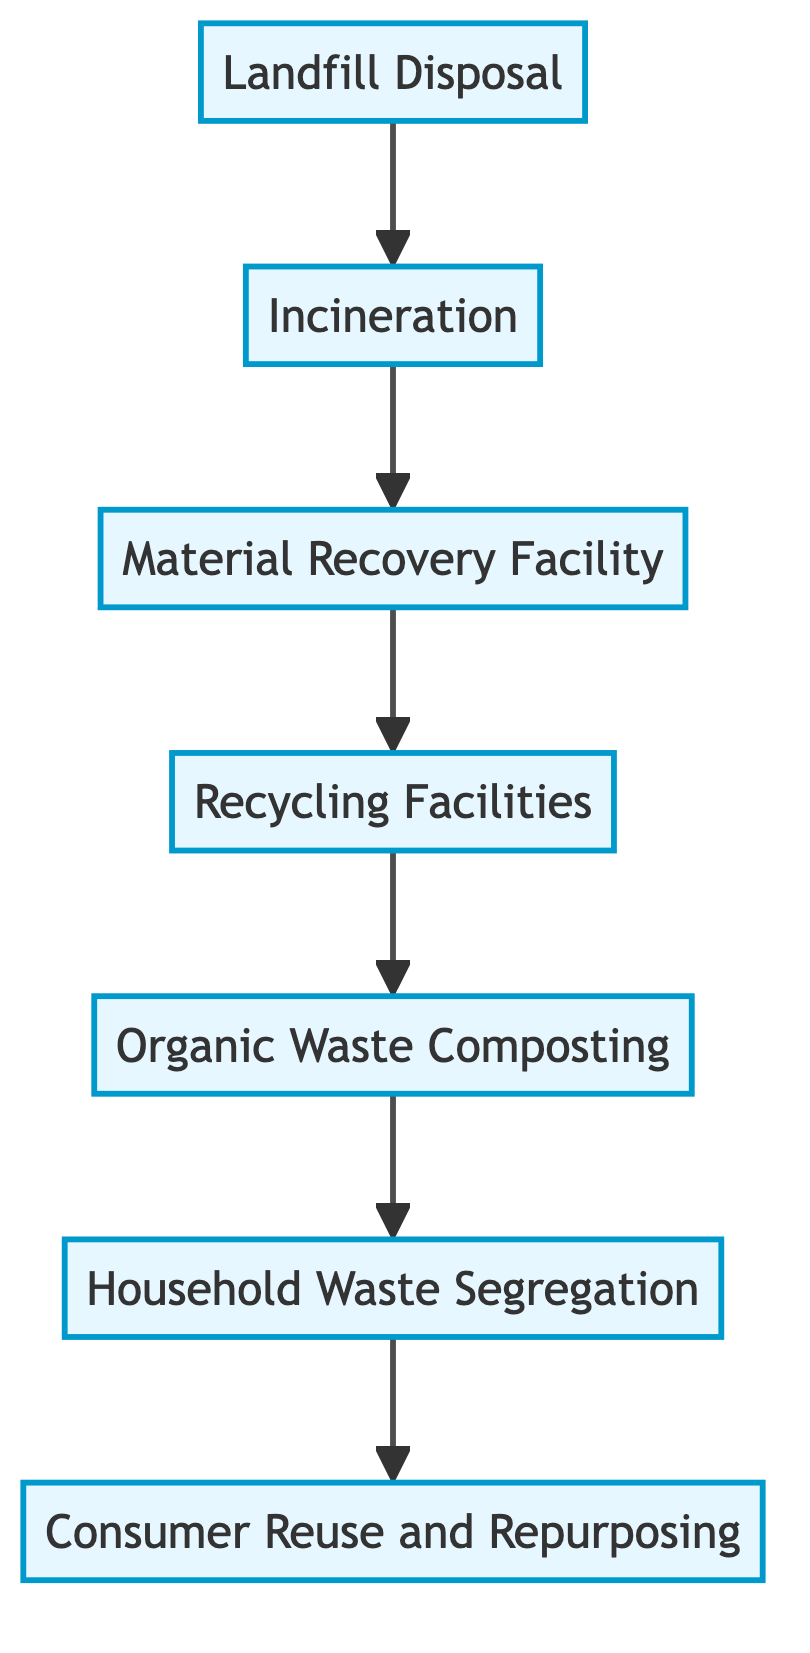What is the first stage in the waste management flow? The flow chart starts at the bottom with Landfill Disposal, which is the initial stage for household waste.
Answer: Landfill Disposal How many stages are there in the waste management process? The flow chart contains a total of seven stages, starting from Landfill Disposal and ending with Consumer Reuse and Repurposing.
Answer: Seven What is the impact of Organic Waste Composting? The diagram states that the impact includes a reduction in landfill use and methane emissions, along with the production of compost.
Answer: Reduction in landfill use and methane emissions Which stage directly precedes Recycling Facilities? The stage directly before Recycling Facilities, according to the flow chart, is the Material Recovery Facility (MRF).
Answer: Material Recovery Facility What type of waste is processed at Recycling Facilities? The Recycling Facilities specifically handle materials such as plastics, metals, and paper for processing into new products.
Answer: Plastics, metals, and paper What is the last step in the waste management flow? In the flow chart, the last stage of waste management is Consumer Reuse and Repurposing, which takes place at the top of the diagram.
Answer: Consumer Reuse and Repurposing Which stage focuses on reducing contamination of recyclable materials? The Household Waste Segregation stage is responsible for increasing the efficiency of recycling and composting while reducing contamination.
Answer: Household Waste Segregation What happens to waste during Incineration? During the Incineration stage, waste is burned at high temperatures to reduce its volume, leading to emissions of harmful pollutants.
Answer: Waste is burned to reduce volume Which stage produces compost that can enrich soil? The Organic Waste Composting stage decomposes biodegradable waste to produce compost beneficial for enriching soil.
Answer: Organic Waste Composting 